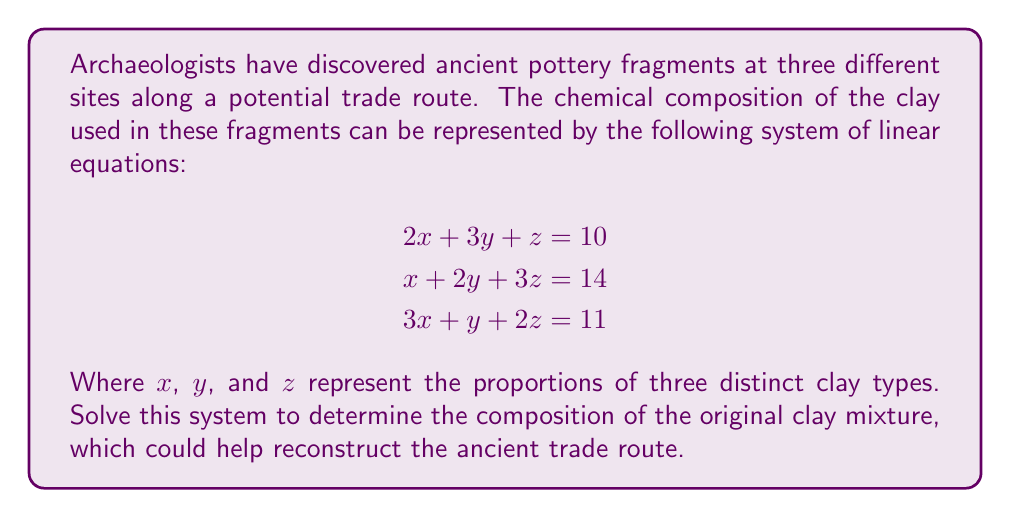Can you answer this question? To solve this system of linear equations, we'll use the Gaussian elimination method:

1. Write the augmented matrix:
   $$\begin{bmatrix}
   2 & 3 & 1 & 10 \\
   1 & 2 & 3 & 14 \\
   3 & 1 & 2 & 11
   \end{bmatrix}$$

2. Subtract 2 times the second row from the first row:
   $$\begin{bmatrix}
   0 & -1 & -5 & -18 \\
   1 & 2 & 3 & 14 \\
   3 & 1 & 2 & 11
   \end{bmatrix}$$

3. Subtract 3 times the second row from the third row:
   $$\begin{bmatrix}
   0 & -1 & -5 & -18 \\
   1 & 2 & 3 & 14 \\
   0 & -5 & -7 & -31
   \end{bmatrix}$$

4. Multiply the first row by -1:
   $$\begin{bmatrix}
   0 & 1 & 5 & 18 \\
   1 & 2 & 3 & 14 \\
   0 & -5 & -7 & -31
   \end{bmatrix}$$

5. Add 5 times the first row to the third row:
   $$\begin{bmatrix}
   0 & 1 & 5 & 18 \\
   1 & 2 & 3 & 14 \\
   0 & 0 & 18 & 59
   \end{bmatrix}$$

6. Divide the third row by 18:
   $$\begin{bmatrix}
   0 & 1 & 5 & 18 \\
   1 & 2 & 3 & 14 \\
   0 & 0 & 1 & \frac{59}{18}
   \end{bmatrix}$$

7. Subtract 5 times the third row from the first row:
   $$\begin{bmatrix}
   0 & 1 & 0 & \frac{13}{18} \\
   1 & 2 & 3 & 14 \\
   0 & 0 & 1 & \frac{59}{18}
   \end{bmatrix}$$

8. Subtract 3 times the third row from the second row:
   $$\begin{bmatrix}
   0 & 1 & 0 & \frac{13}{18} \\
   1 & 2 & 0 & \frac{73}{6} \\
   0 & 0 & 1 & \frac{59}{18}
   \end{bmatrix}$$

9. Subtract 2 times the first row from the second row:
   $$\begin{bmatrix}
   0 & 1 & 0 & \frac{13}{18} \\
   1 & 0 & 0 & \frac{11}{3} \\
   0 & 0 & 1 & \frac{59}{18}
   \end{bmatrix}$$

Now we can read off the solution:
$y = \frac{13}{18}$
$x = \frac{11}{3}$
$z = \frac{59}{18}$
Answer: $x = \frac{11}{3}$, $y = \frac{13}{18}$, $z = \frac{59}{18}$ 